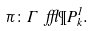Convert formula to latex. <formula><loc_0><loc_0><loc_500><loc_500>\pi \colon \Gamma \ f f l \P P ^ { 1 } _ { k } .</formula> 